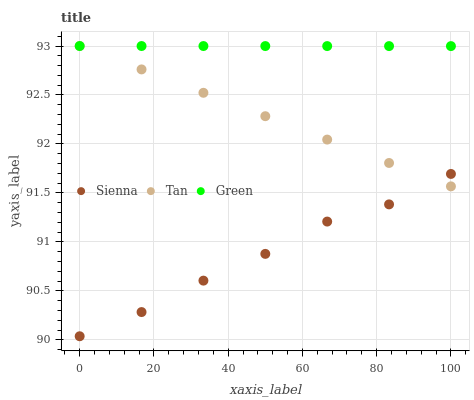Does Sienna have the minimum area under the curve?
Answer yes or no. Yes. Does Green have the maximum area under the curve?
Answer yes or no. Yes. Does Tan have the minimum area under the curve?
Answer yes or no. No. Does Tan have the maximum area under the curve?
Answer yes or no. No. Is Green the smoothest?
Answer yes or no. Yes. Is Sienna the roughest?
Answer yes or no. Yes. Is Tan the smoothest?
Answer yes or no. No. Is Tan the roughest?
Answer yes or no. No. Does Sienna have the lowest value?
Answer yes or no. Yes. Does Tan have the lowest value?
Answer yes or no. No. Does Green have the highest value?
Answer yes or no. Yes. Is Sienna less than Green?
Answer yes or no. Yes. Is Green greater than Sienna?
Answer yes or no. Yes. Does Green intersect Tan?
Answer yes or no. Yes. Is Green less than Tan?
Answer yes or no. No. Is Green greater than Tan?
Answer yes or no. No. Does Sienna intersect Green?
Answer yes or no. No. 